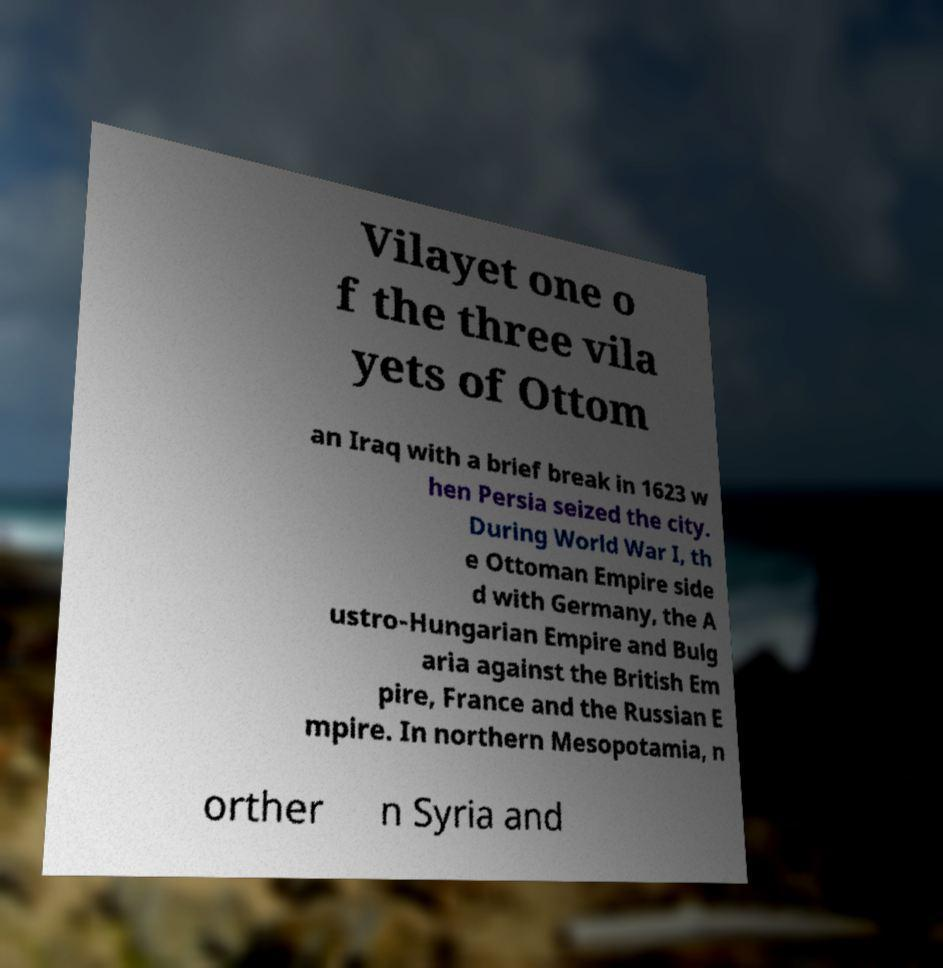Can you accurately transcribe the text from the provided image for me? Vilayet one o f the three vila yets of Ottom an Iraq with a brief break in 1623 w hen Persia seized the city. During World War I, th e Ottoman Empire side d with Germany, the A ustro-Hungarian Empire and Bulg aria against the British Em pire, France and the Russian E mpire. In northern Mesopotamia, n orther n Syria and 